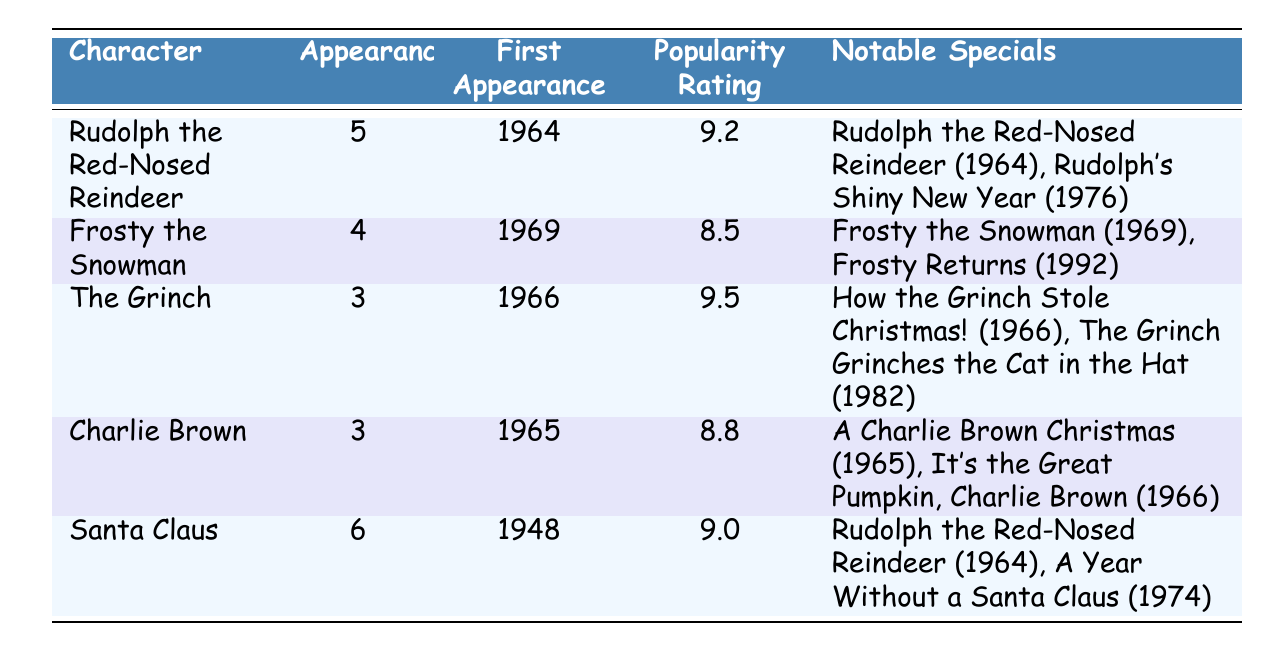What character has the highest popularity rating? The table indicates popularity ratings next to each character. Comparing the ratings, The Grinch has the highest rating at 9.5.
Answer: The Grinch How many characters have appeared in more than four specials? By examining the "Appearances" column, Santa Claus has 6 appearances, and Rudolph the Red-Nosed Reindeer has 5 appearances. Therefore, there are 2 characters with more than four appearances.
Answer: 2 Which character made their first appearance in 1965? The "First Appearance" column shows that Charlie Brown is listed as having first appeared in 1965.
Answer: Charlie Brown What is the average popularity rating of the characters? The popularity ratings are 9.2, 8.5, 9.5, 8.8, and 9.0. To find the average: (9.2 + 8.5 + 9.5 + 8.8 + 9.0) = 45.0. Dividing by 5 gives an average of 9.0.
Answer: 9.0 Did Frosty the Snowman appear in any specials after 1990? According to the table, Frosty the Snowman appeared in Frosty Returns in 1992, which is after 1990. Therefore, the answer is yes.
Answer: Yes Which character appeared in the most specials? Looking at the "Notable Specials" column, we see that Santa Claus has appeared in three specials, while Rudolph the Red-Nosed Reindeer has also appeared in three. Therefore, more than one character holds this distinction.
Answer: Santa Claus and Rudolph the Red-Nosed Reindeer Was Rudolph the Red-Nosed Reindeer introduced before the Grinch? The table indicates that Rudolph the Red-Nosed Reindeer first appeared in 1964, while The Grinch first appeared in 1966. This shows that Rudolph was introduced before the Grinch.
Answer: Yes What is the difference in the number of appearances between Rudolph and Frosty? Rudolph has 5 appearances, and Frosty has 4. The difference is 5 - 4 = 1.
Answer: 1 